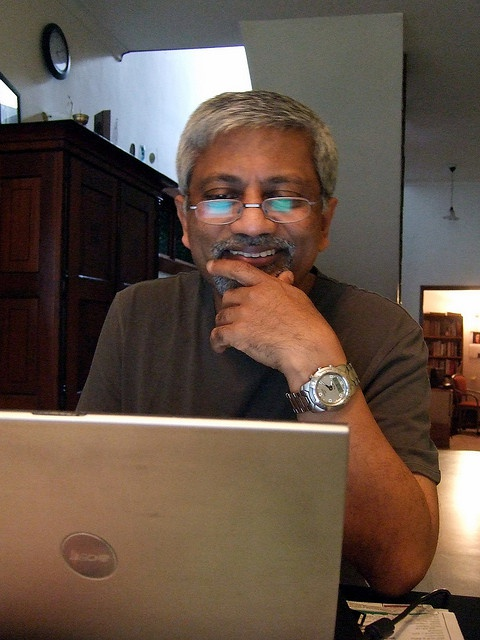Describe the objects in this image and their specific colors. I can see people in gray, black, maroon, and brown tones, laptop in gray, brown, and maroon tones, clock in gray, darkgray, and black tones, clock in gray, black, and purple tones, and book in gray, maroon, black, and brown tones in this image. 